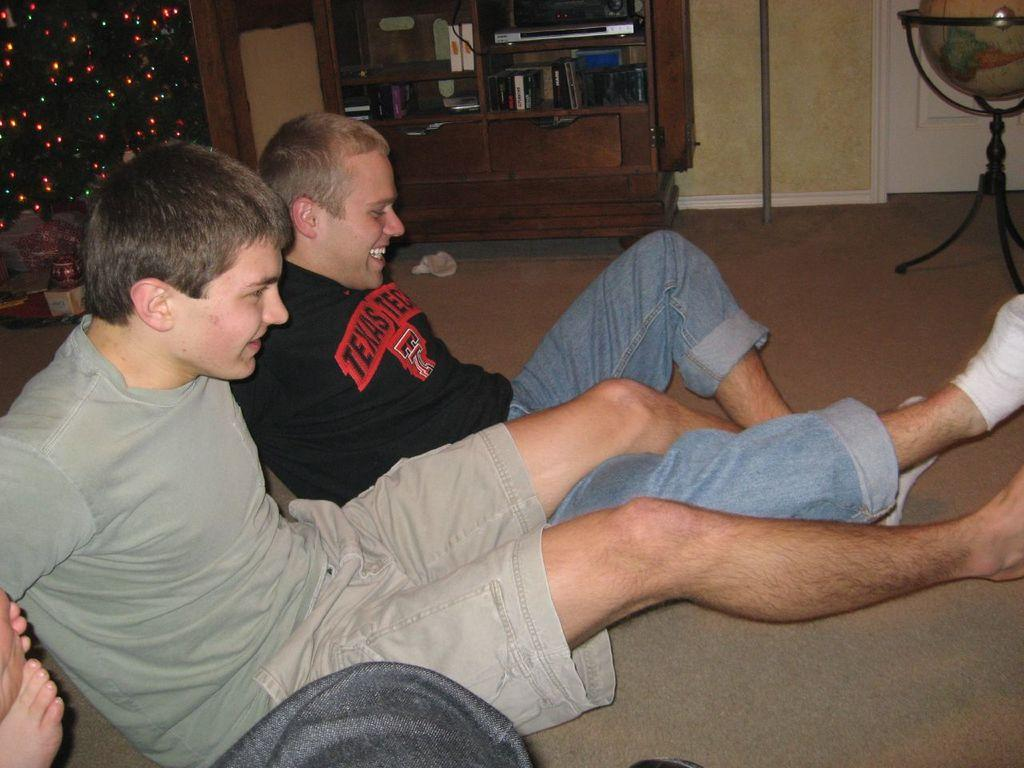<image>
Relay a brief, clear account of the picture shown. A man in a Texas shirt tangles his legs with another man on the floor. 